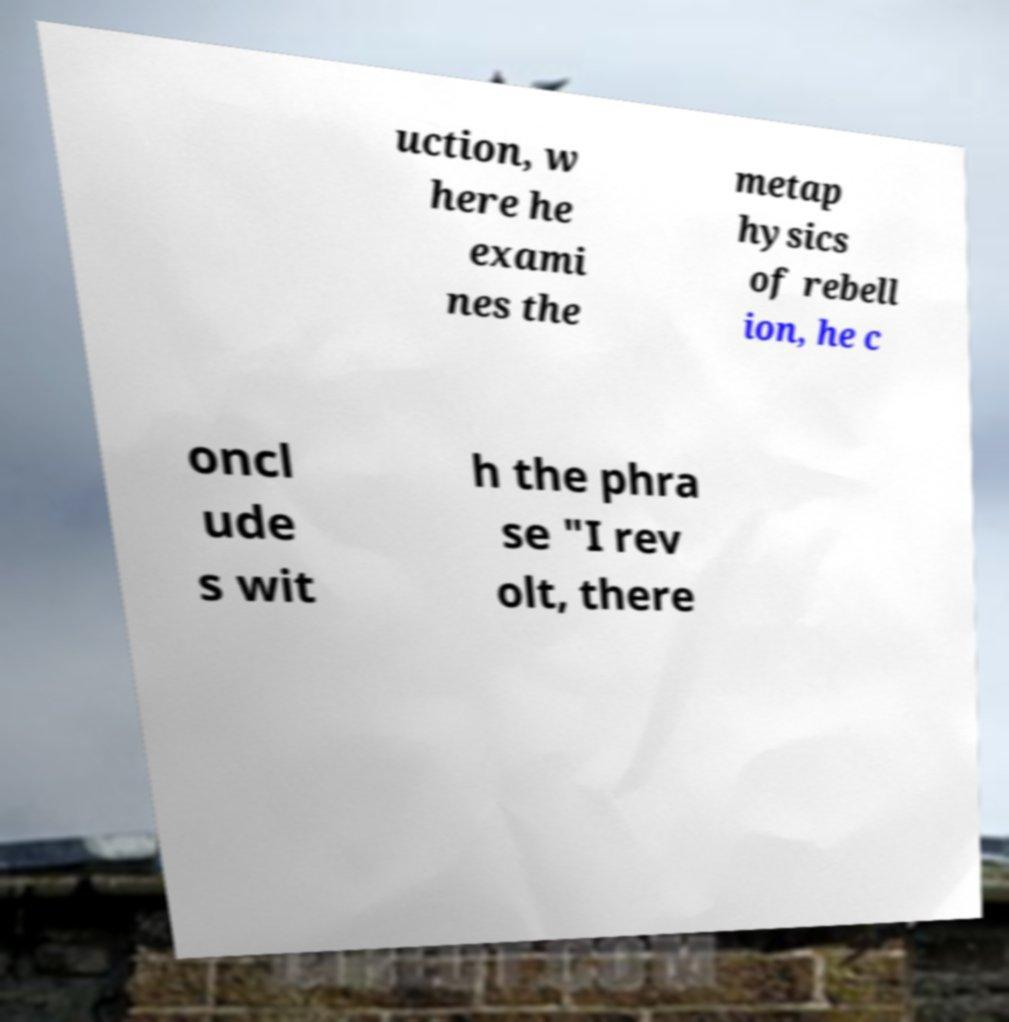I need the written content from this picture converted into text. Can you do that? uction, w here he exami nes the metap hysics of rebell ion, he c oncl ude s wit h the phra se "I rev olt, there 